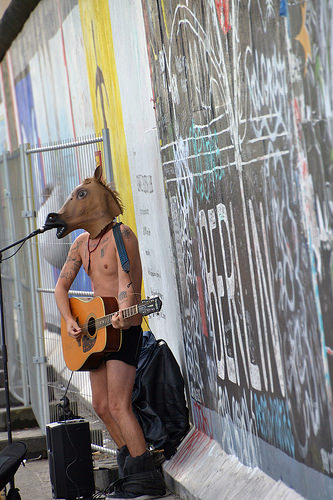<image>
Is the guitar under the horse mask? Yes. The guitar is positioned underneath the horse mask, with the horse mask above it in the vertical space. 